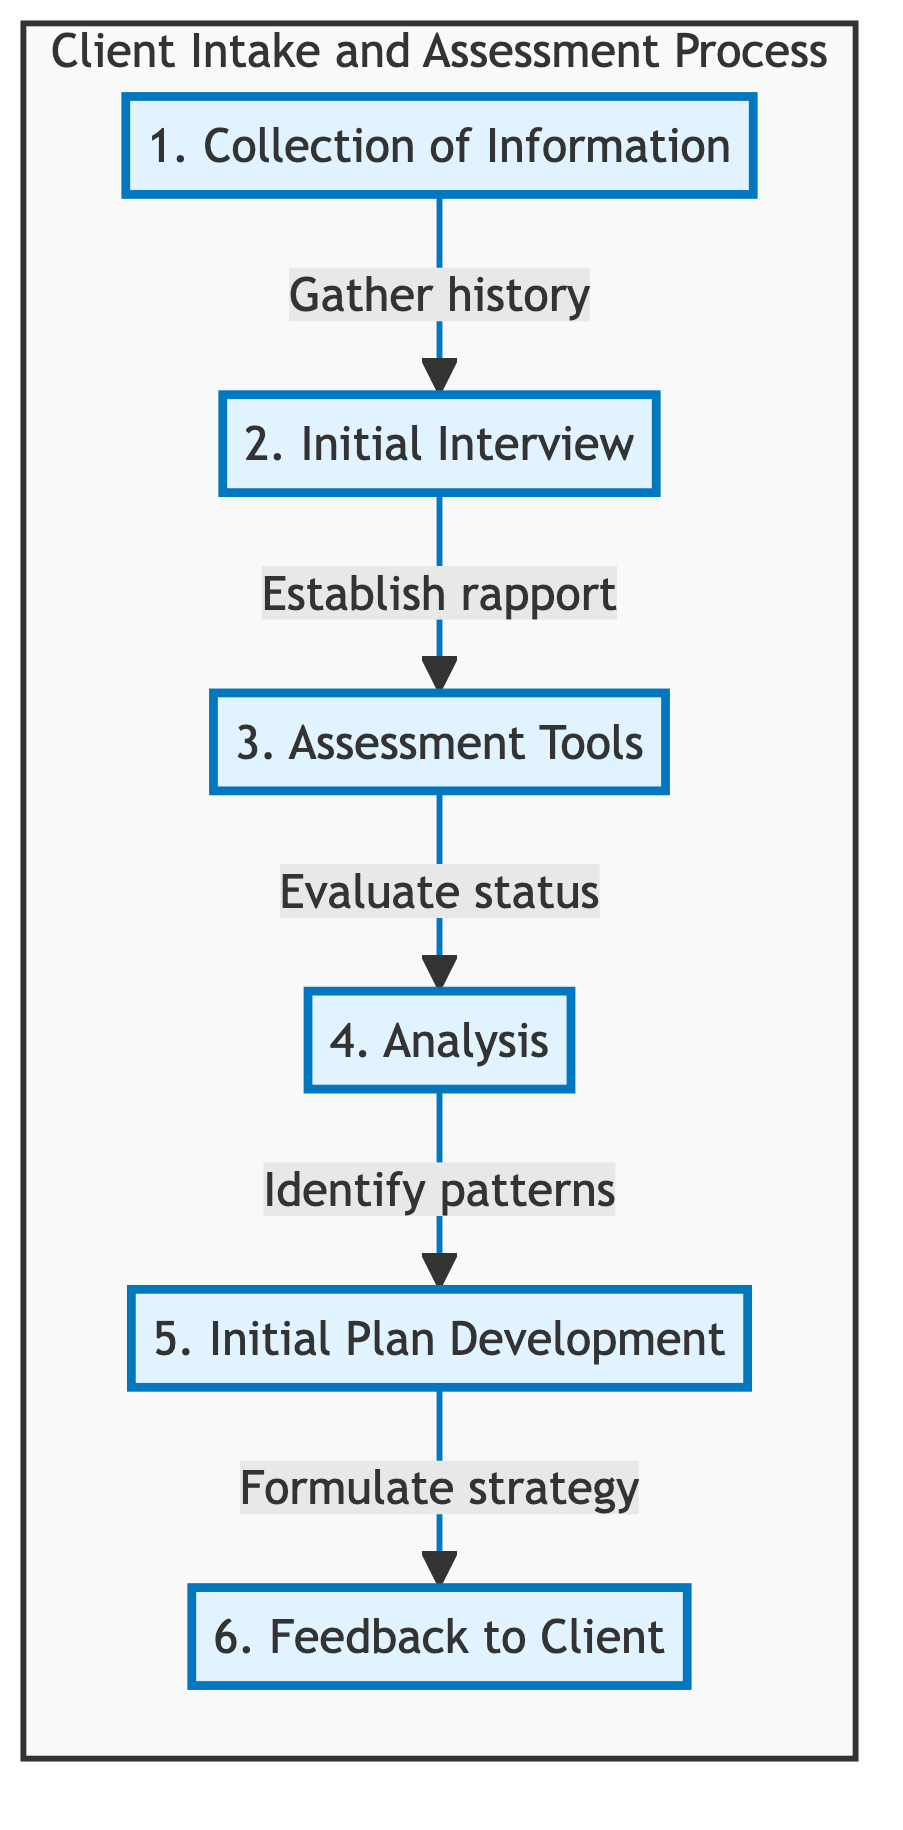What is the first step in the Client Intake and Assessment Process? The first step, as represented in the flowchart, is "Collection of Information," which indicates that this is the starting point of the process.
Answer: Collection of Information How many steps are in the Client Intake and Assessment Process? The diagram clearly shows six distinct steps from "Collection of Information" to "Feedback to Client," making it easy to count them.
Answer: 6 What is the purpose of the "Initial Interview"? Referring to the flowchart, the "Initial Interview" aims to conduct a face-to-face meeting to understand the client's situation and establish rapport, highlighting this meeting's importance in the process.
Answer: Conduct a face-to-face meeting Which step comes after "Assessment Tools"? Following the flowchart, "Analysis" directly follows "Assessment Tools," indicating a progression in the process after utilizing assessment tools.
Answer: Analysis What is the last step in the Client Intake and Assessment Process? The last step, as indicated in the flowchart, is "Feedback to Client," which signifies the conclusion of this particular process.
Answer: Feedback to Client In which step are standardized tools utilized? The diagram shows that the step named "Assessment Tools" is specifically focused on the utilization of standardized tools and questionnaires for evaluation purposes.
Answer: Assessment Tools What follows the "Analysis" step? According to the flowchart, "Initial Plan Development" comes after "Analysis," indicating the next stage of formulating a strategy based on analyzed data.
Answer: Initial Plan Development What elements are included in the "Feedback to Client"? The flowchart lists "Communicating Findings," "Discussing Treatment Options," and "Addressing Client's Questions and Concerns" as part of the "Feedback to Client," capturing the main components involved in that step.
Answer: Communicating Findings, Discussing Treatment Options, Addressing Client's Questions and Concerns How is rapport established in the Initial Interview? Within the flowchart, the essential component of "Building Trust" is a key method mentioned for establishing rapport during the Initial Interview.
Answer: Building Trust 